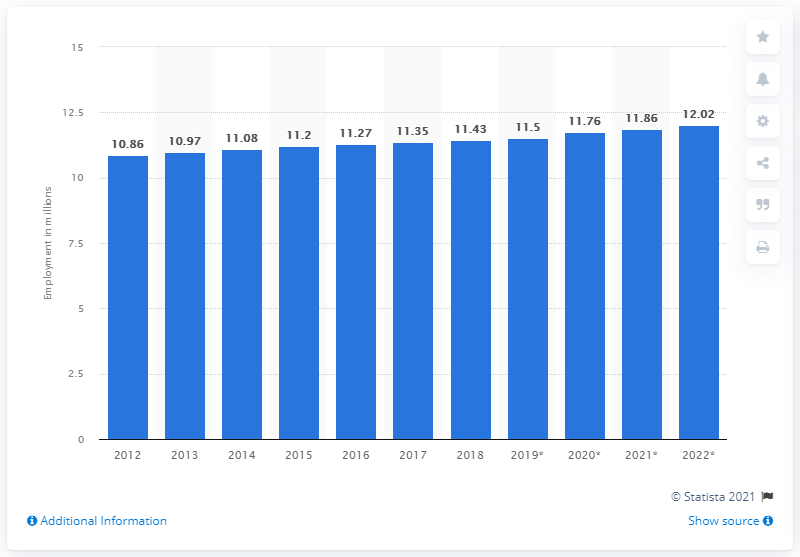Outline some significant characteristics in this image. In 2018, the number of people employed in Taiwan was 11.5 million. 